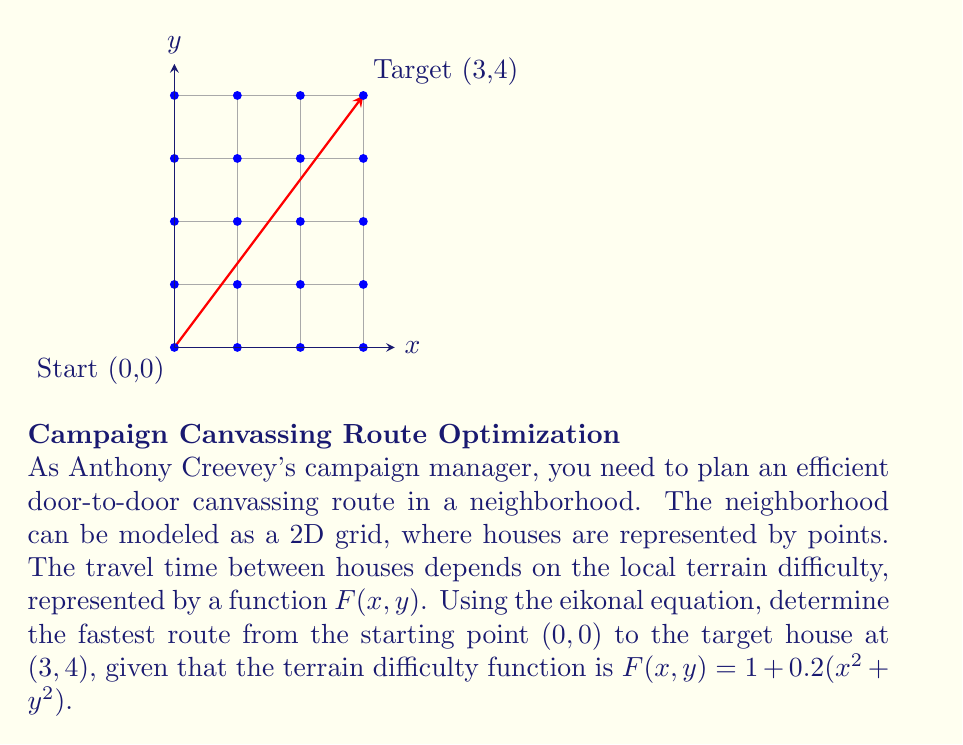Could you help me with this problem? To solve this problem, we'll use the eikonal equation and the given terrain difficulty function. The eikonal equation in 2D is:

$$|\nabla T(x,y)| = F(x,y)$$

where $T(x,y)$ is the travel time function and $F(x,y)$ is the terrain difficulty function.

Step 1: Set up the eikonal equation with the given $F(x,y)$:
$$\sqrt{(\frac{\partial T}{\partial x})^2 + (\frac{\partial T}{\partial y})^2} = 1 + 0.2(x^2 + y^2)$$

Step 2: To solve this non-linear PDE, we can use the Fast Marching Method (FMM) or other numerical methods. However, for this explanation, we'll use a simplified approach.

Step 3: Assume the optimal path is approximately a straight line from $(0,0)$ to $(3,4)$. The path can be parameterized as:
$$x(t) = 3t, y(t) = 4t, \text{ where } 0 \leq t \leq 1$$

Step 4: Calculate the path length:
$$L = \sqrt{3^2 + 4^2} = 5$$

Step 5: Integrate the terrain difficulty function along this path:
$$T = \int_0^1 F(x(t), y(t)) \sqrt{(\frac{dx}{dt})^2 + (\frac{dy}{dt})^2} dt$$
$$T = \int_0^1 (1 + 0.2((3t)^2 + (4t)^2)) \cdot 5 dt$$
$$T = \int_0^1 (5 + 5(1.8t^2)) dt$$
$$T = [5t + 3t^3]_0^1 = 5 + 3 = 8$$

Step 6: The travel time along this approximate optimal path is 8 units.

Note: This is an approximation. A more accurate solution would require solving the full eikonal equation numerically, which would likely result in a slightly curved path and a marginally shorter travel time.
Answer: $T \approx 8$ time units 